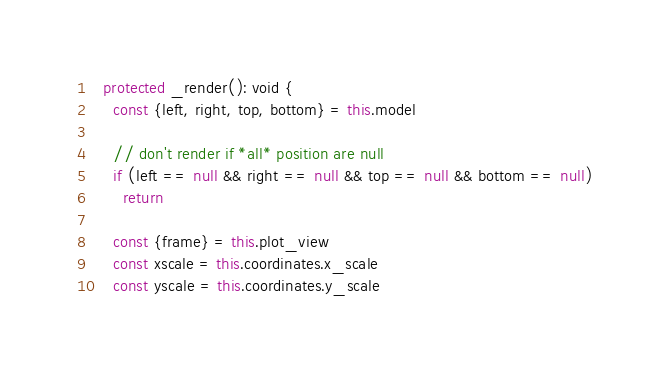<code> <loc_0><loc_0><loc_500><loc_500><_TypeScript_>  protected _render(): void {
    const {left, right, top, bottom} = this.model

    // don't render if *all* position are null
    if (left == null && right == null && top == null && bottom == null)
      return

    const {frame} = this.plot_view
    const xscale = this.coordinates.x_scale
    const yscale = this.coordinates.y_scale
</code> 